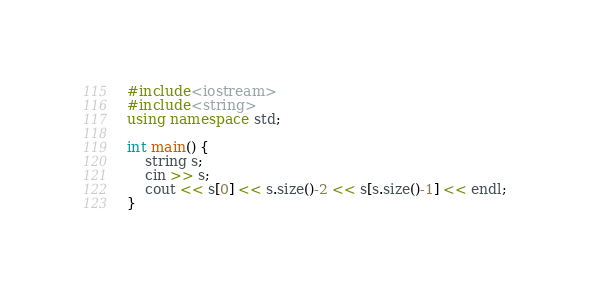Convert code to text. <code><loc_0><loc_0><loc_500><loc_500><_C++_>#include<iostream>
#include<string>
using namespace std;

int main() {
    string s;
    cin >> s;
    cout << s[0] << s.size()-2 << s[s.size()-1] << endl;
}</code> 